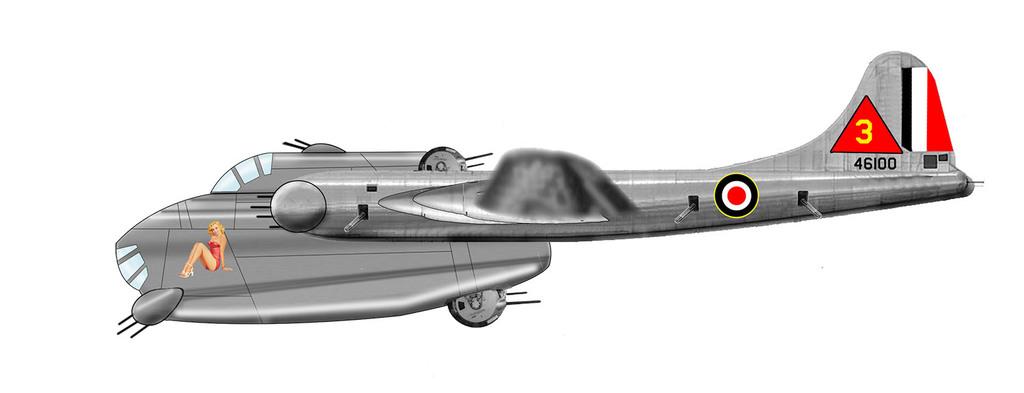What number is on the back of this plane?
Provide a short and direct response. 3. 